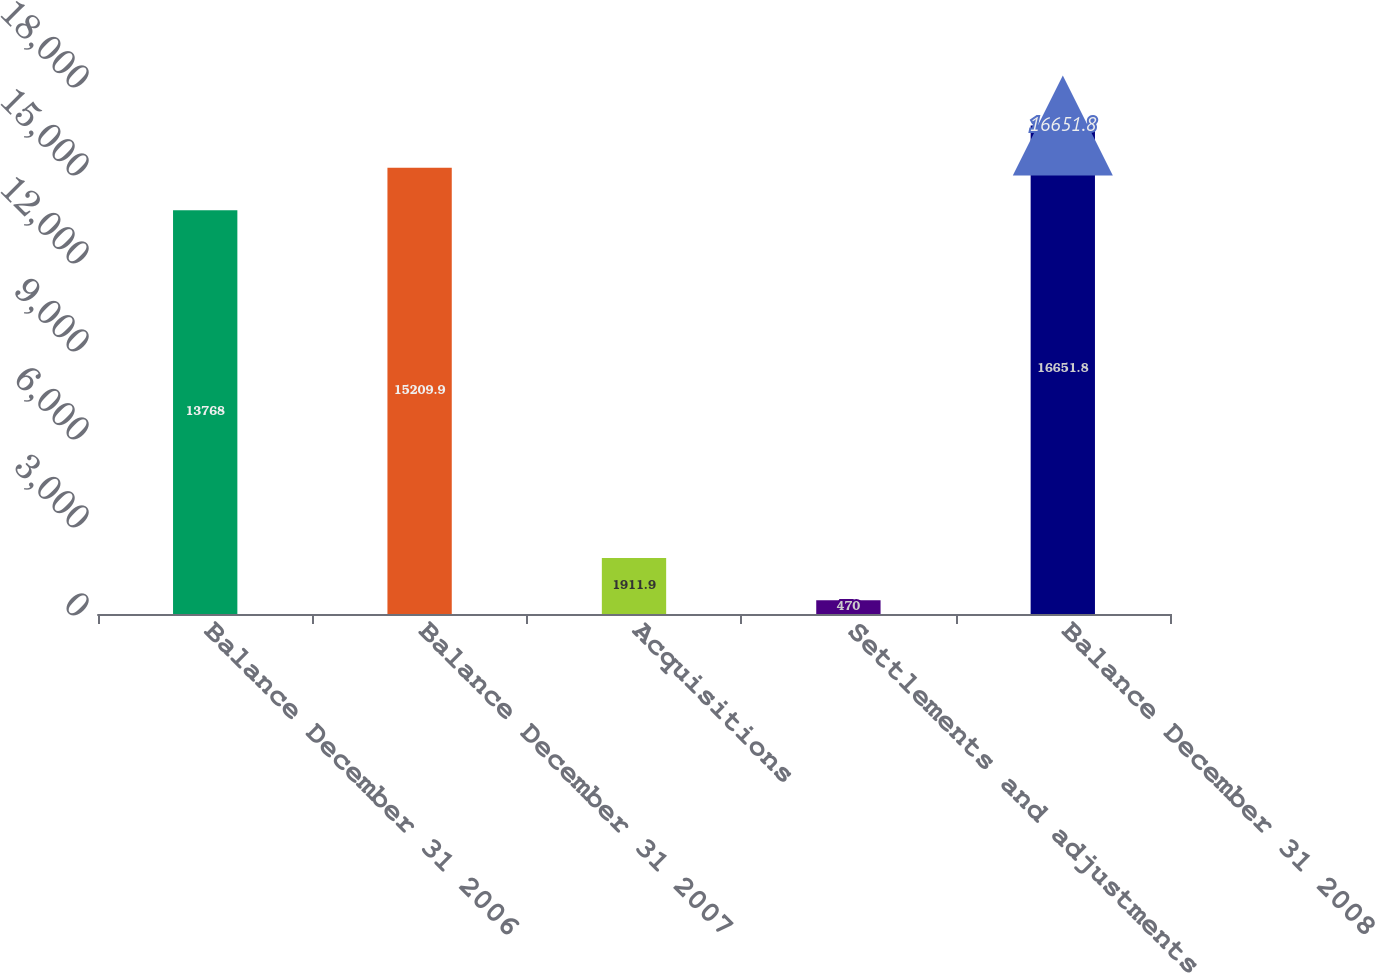Convert chart. <chart><loc_0><loc_0><loc_500><loc_500><bar_chart><fcel>Balance December 31 2006<fcel>Balance December 31 2007<fcel>Acquisitions<fcel>Settlements and adjustments<fcel>Balance December 31 2008<nl><fcel>13768<fcel>15209.9<fcel>1911.9<fcel>470<fcel>16651.8<nl></chart> 